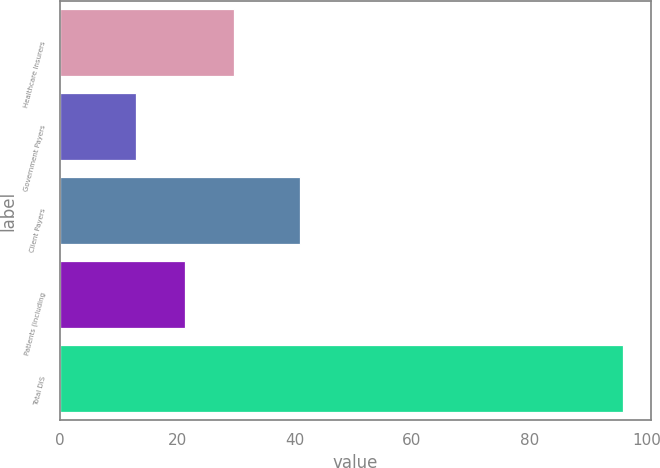<chart> <loc_0><loc_0><loc_500><loc_500><bar_chart><fcel>Healthcare Insurers<fcel>Government Payers<fcel>Client Payers<fcel>Patients (including<fcel>Total DIS<nl><fcel>29.6<fcel>13<fcel>41<fcel>21.3<fcel>96<nl></chart> 